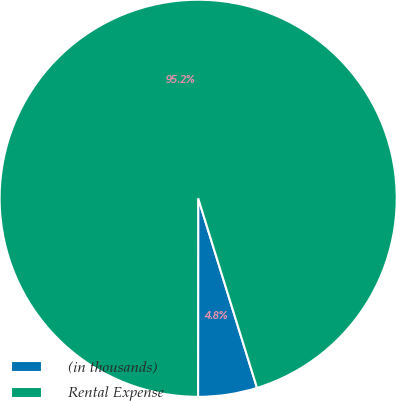<chart> <loc_0><loc_0><loc_500><loc_500><pie_chart><fcel>(in thousands)<fcel>Rental Expense<nl><fcel>4.8%<fcel>95.2%<nl></chart> 